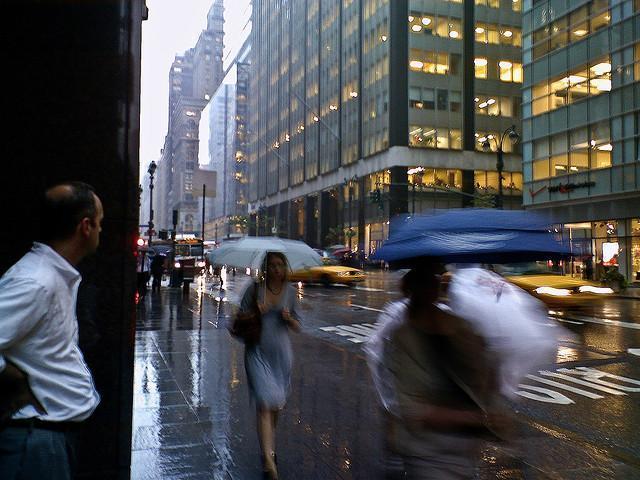What is the man wearing white shirt waiting for?
Pick the correct solution from the four options below to address the question.
Options: Rain stopping, crossing street, his kid, bus. Rain stopping. 